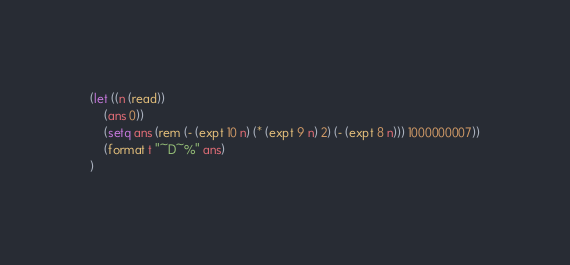<code> <loc_0><loc_0><loc_500><loc_500><_Lisp_>(let ((n (read))
    (ans 0))
    (setq ans (rem (- (expt 10 n) (* (expt 9 n) 2) (- (expt 8 n))) 1000000007))
    (format t "~D~%" ans)
)</code> 